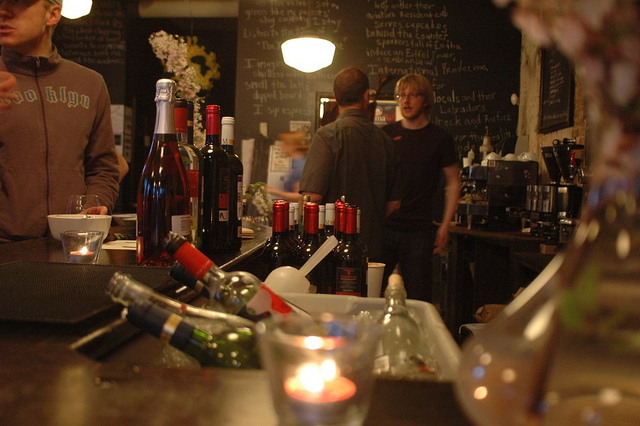What types of beverages can be seen on the counter in front of the person? The counter in the image contains several types of beverages, including what appear to be bottles of red wine, and possibly some spirits or liqueurs. 